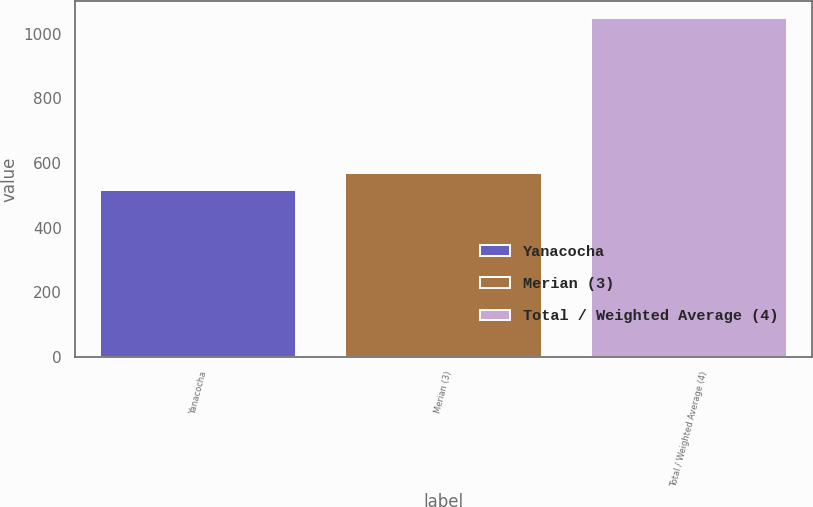<chart> <loc_0><loc_0><loc_500><loc_500><bar_chart><fcel>Yanacocha<fcel>Merian (3)<fcel>Total / Weighted Average (4)<nl><fcel>515<fcel>568.4<fcel>1049<nl></chart> 